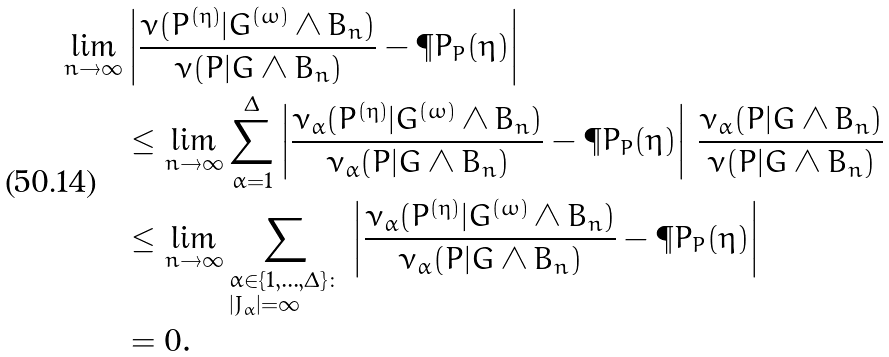Convert formula to latex. <formula><loc_0><loc_0><loc_500><loc_500>\lim _ { n \to \infty } & \left | \frac { \nu ( P ^ { ( \eta ) } | G ^ { ( \omega ) } \wedge B _ { n } ) } { \nu ( P | G \wedge B _ { n } ) } - \P P _ { P } ( \eta ) \right | \\ & \leq \lim _ { n \to \infty } \sum _ { \alpha = 1 } ^ { \Delta } \left | \frac { \nu _ { \alpha } ( P ^ { ( \eta ) } | G ^ { ( \omega ) } \wedge B _ { n } ) } { \nu _ { \alpha } ( P | G \wedge B _ { n } ) } - \P P _ { P } ( \eta ) \right | \, \frac { \nu _ { \alpha } ( P | G \wedge B _ { n } ) } { \nu ( P | G \wedge B _ { n } ) } \\ & \leq \lim _ { n \to \infty } \sum _ { \begin{subarray} { c } \alpha \in \{ 1 , \dots , \Delta \} \colon \\ | J _ { \alpha } | = \infty \end{subarray} } \, \left | \frac { \nu _ { \alpha } ( P ^ { ( \eta ) } | G ^ { ( \omega ) } \wedge B _ { n } ) } { \nu _ { \alpha } ( P | G \wedge B _ { n } ) } - \P P _ { P } ( \eta ) \right | \\ & = 0 .</formula> 